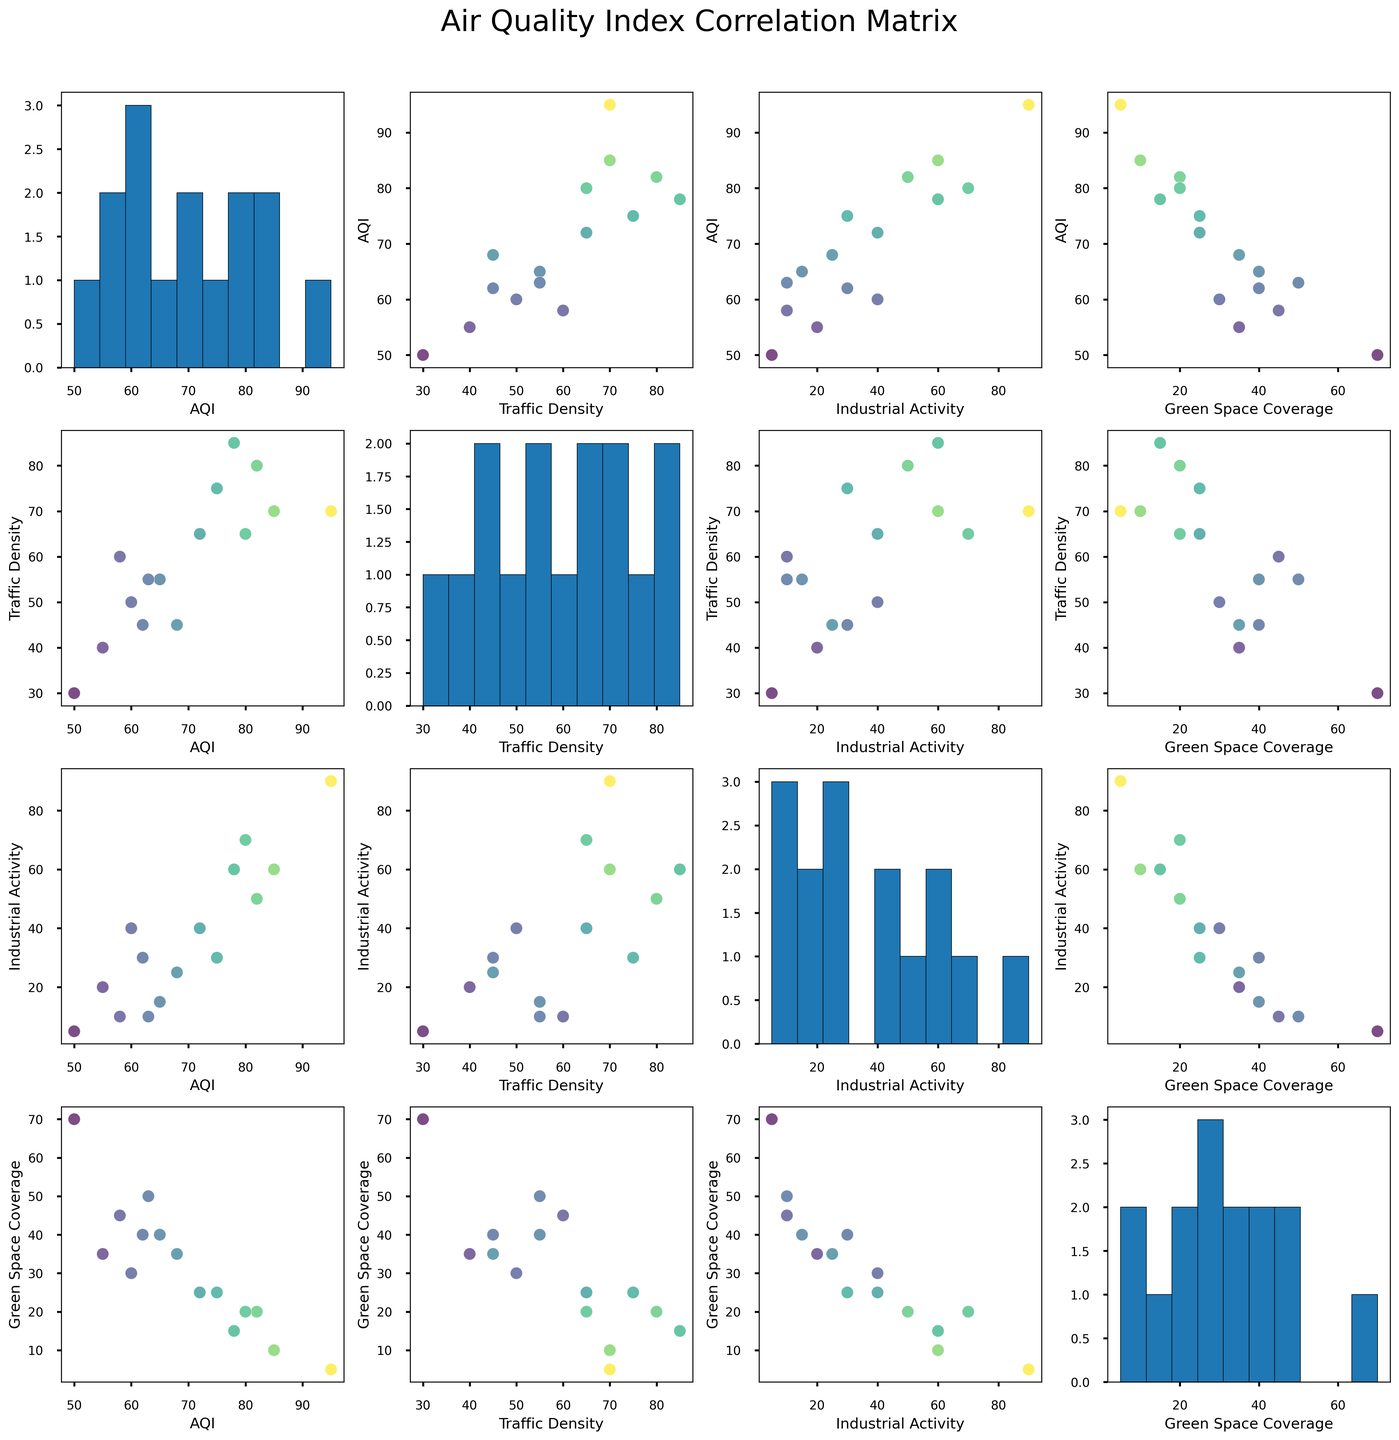What's the title of the figure? The title of the figure is written at the top of the plot in a large, bold font. It provides an overview of what the figure is about.
Answer: Air Quality Index Correlation Matrix How many variables are compared in the scatterplot matrix? By counting the number of different plots along one row or column, we can see how many variables are being compared.
Answer: 4 Which location has the highest AQI value? By looking at the color intensity across different points and checking the corresponding location in the data, we can identify the location with the highest AQI value.
Answer: Industrial Park In which pairwise comparison do you notice a negative correlation between Green Space Coverage and another variable? Look for scatterplots where the Green Space Coverage is plotted against another variable, and the points form a downward trend. Verify to which variables this pattern applies.
Answer: Green Space Coverage vs. Industrial Activity Are there any positive correlations visible between Traffic Density and other variables? Examine the scatterplots where Traffic Density is one of the variables. If the points form an upward trend when paired with another variable, a positive correlation is present.
Answer: Yes, with AQI What is the overall trend between Industrial Activity and AQI? Observe the scatterplot showing Industrial Activity against AQI. Determine if the points form a downward, upward, or no clear trend.
Answer: Positive trend Which comparison shows the largest spread in Green Space Coverage values? Identify which scatterplot has Green Space Coverage on one axis and then check which plot displays the widest range of values on the other axis.
Answer: Green Space Coverage vs. AQI How is the distribution of Traffic Density depicted in the matrix? Look for the plot with Traffic Density on both axes (usually a diagonal plot). This plot would show the distribution of Traffic Density values.
Answer: Histogram What is the visual relationship between AQI and Traffic Density? Find the scatterplot of AQI versus Traffic Density. Determine the pattern formed by the points to understand their relationship.
Answer: Positive correlation Which locations fall under the lowest AQI range based on the scatterplots? By analyzing the scatterplots for color intensity and checking the corresponding locations, we can identify regions with the lowest AQI values.
Answer: Green Belt, Suburban Area 